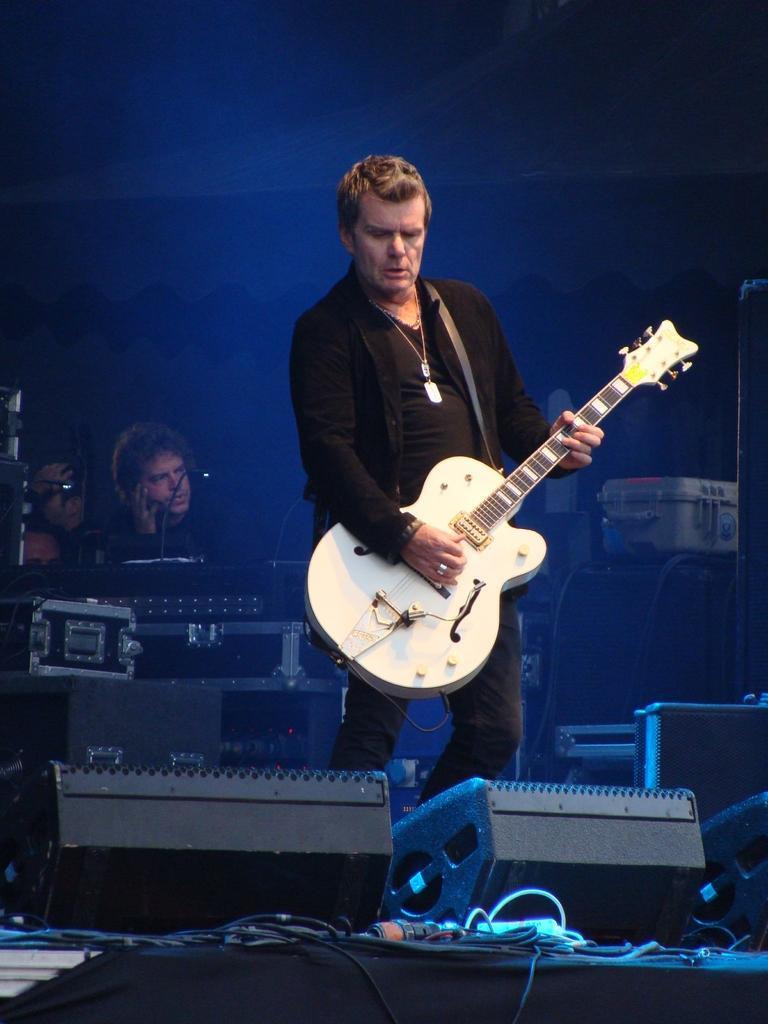In one or two sentences, can you explain what this image depicts? In the center of the image, we can see a person wearing and holding a guitar and in the background, there are some other people and we can see musical instruments and there are cables. 